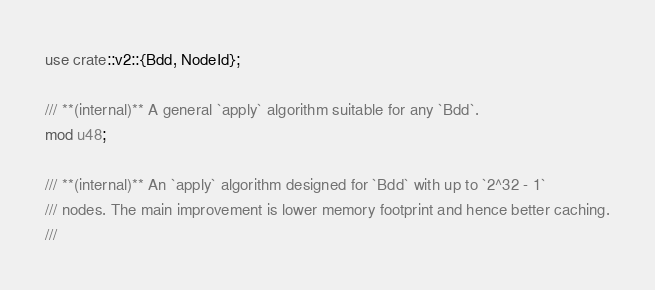<code> <loc_0><loc_0><loc_500><loc_500><_Rust_>use crate::v2::{Bdd, NodeId};

/// **(internal)** A general `apply` algorithm suitable for any `Bdd`.
mod u48;

/// **(internal)** An `apply` algorithm designed for `Bdd` with up to `2^32 - 1`
/// nodes. The main improvement is lower memory footprint and hence better caching.
///</code> 